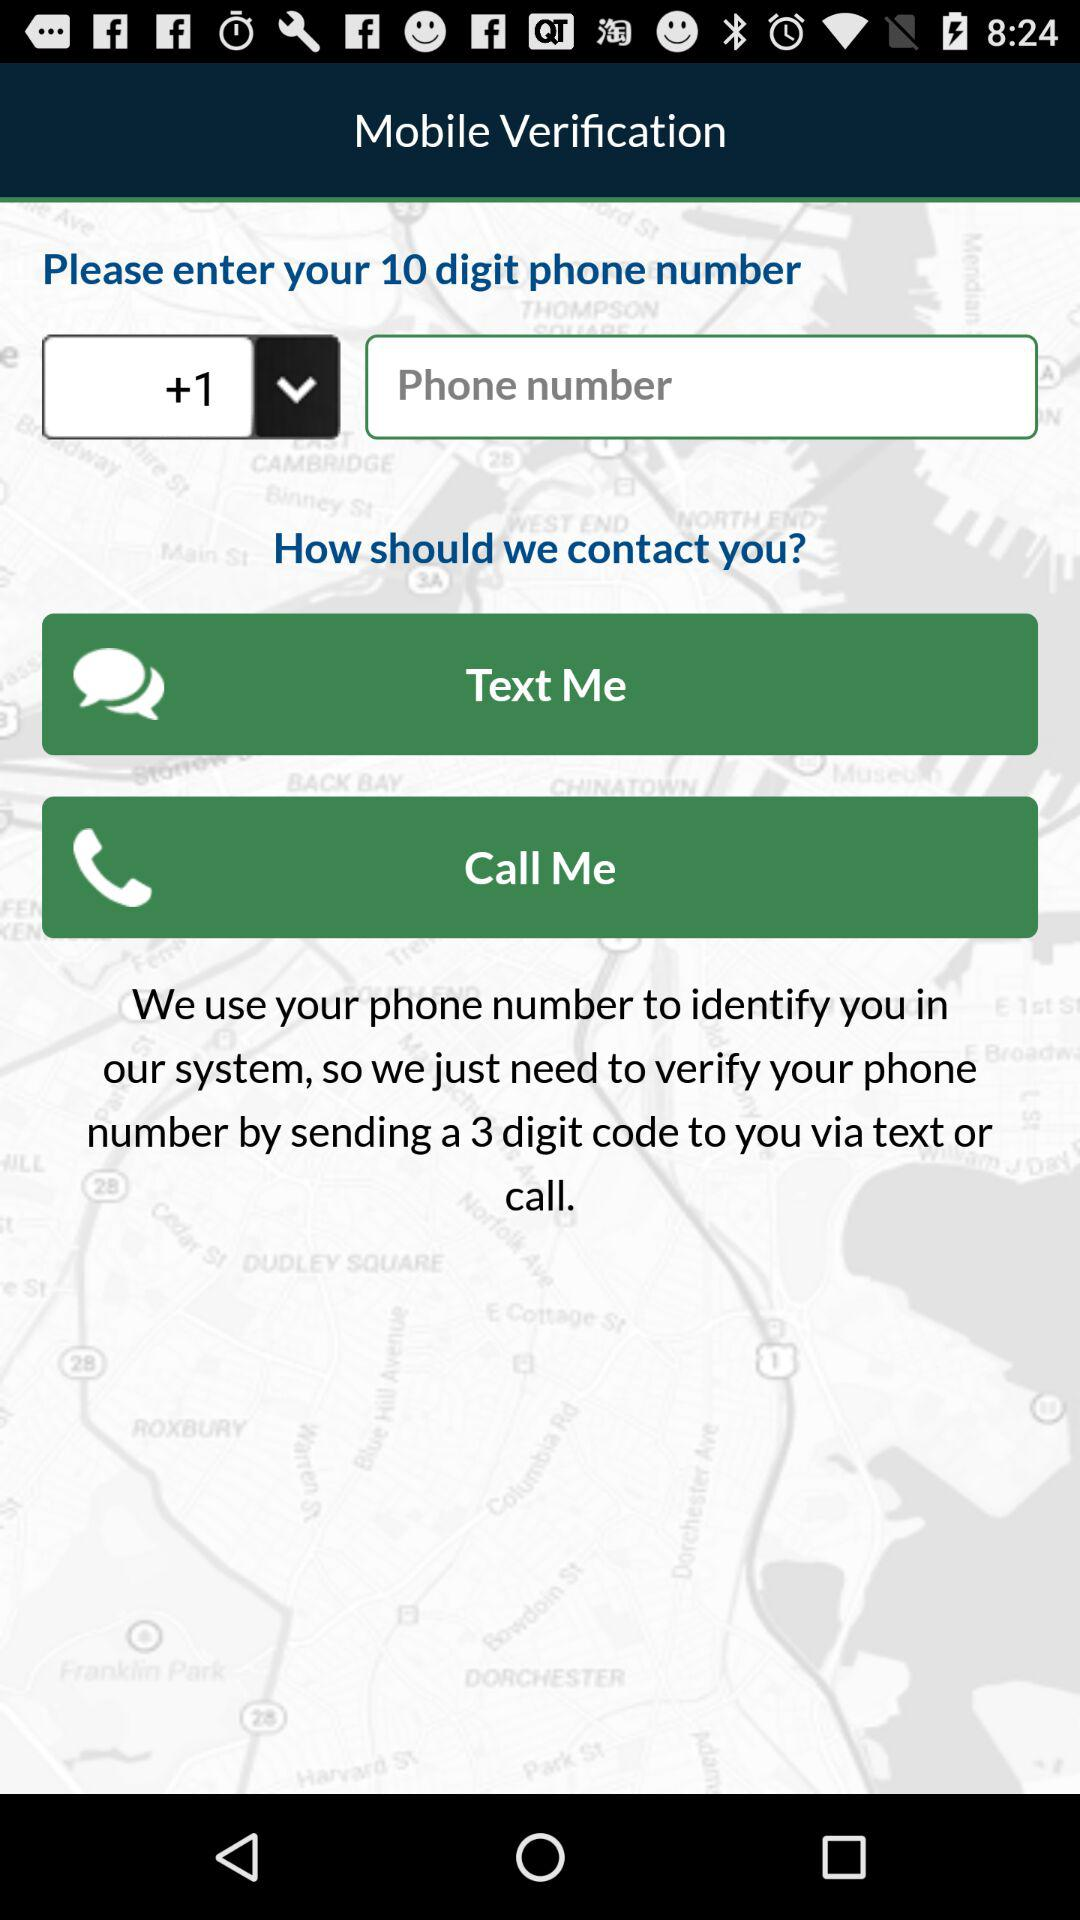How many digits are in the phone number input field?
Answer the question using a single word or phrase. 10 